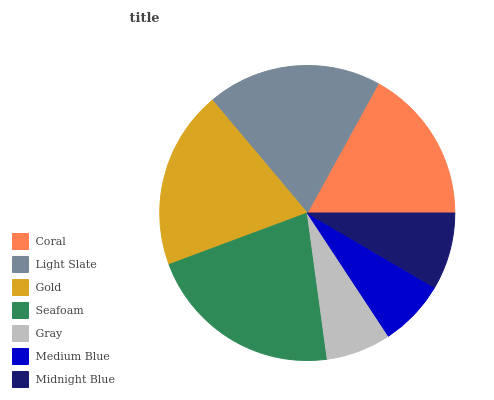Is Gray the minimum?
Answer yes or no. Yes. Is Seafoam the maximum?
Answer yes or no. Yes. Is Light Slate the minimum?
Answer yes or no. No. Is Light Slate the maximum?
Answer yes or no. No. Is Light Slate greater than Coral?
Answer yes or no. Yes. Is Coral less than Light Slate?
Answer yes or no. Yes. Is Coral greater than Light Slate?
Answer yes or no. No. Is Light Slate less than Coral?
Answer yes or no. No. Is Coral the high median?
Answer yes or no. Yes. Is Coral the low median?
Answer yes or no. Yes. Is Gray the high median?
Answer yes or no. No. Is Gold the low median?
Answer yes or no. No. 